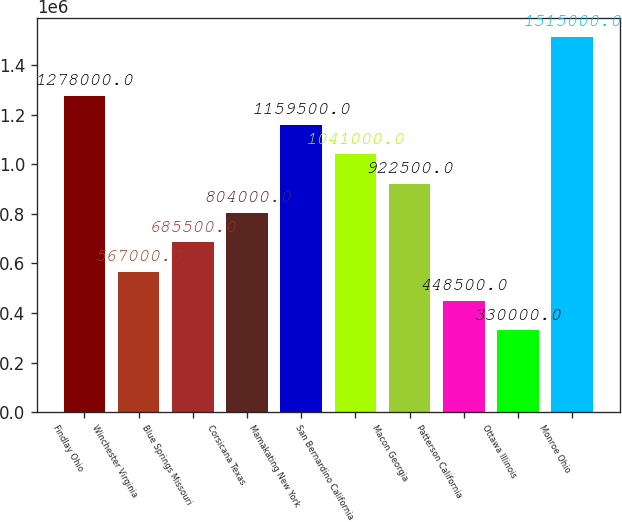Convert chart to OTSL. <chart><loc_0><loc_0><loc_500><loc_500><bar_chart><fcel>Findlay Ohio<fcel>Winchester Virginia<fcel>Blue Springs Missouri<fcel>Corsicana Texas<fcel>Mamakating New York<fcel>San Bernardino California<fcel>Macon Georgia<fcel>Patterson California<fcel>Ottawa Illinois<fcel>Monroe Ohio<nl><fcel>1.278e+06<fcel>567000<fcel>685500<fcel>804000<fcel>1.1595e+06<fcel>1.041e+06<fcel>922500<fcel>448500<fcel>330000<fcel>1.515e+06<nl></chart> 